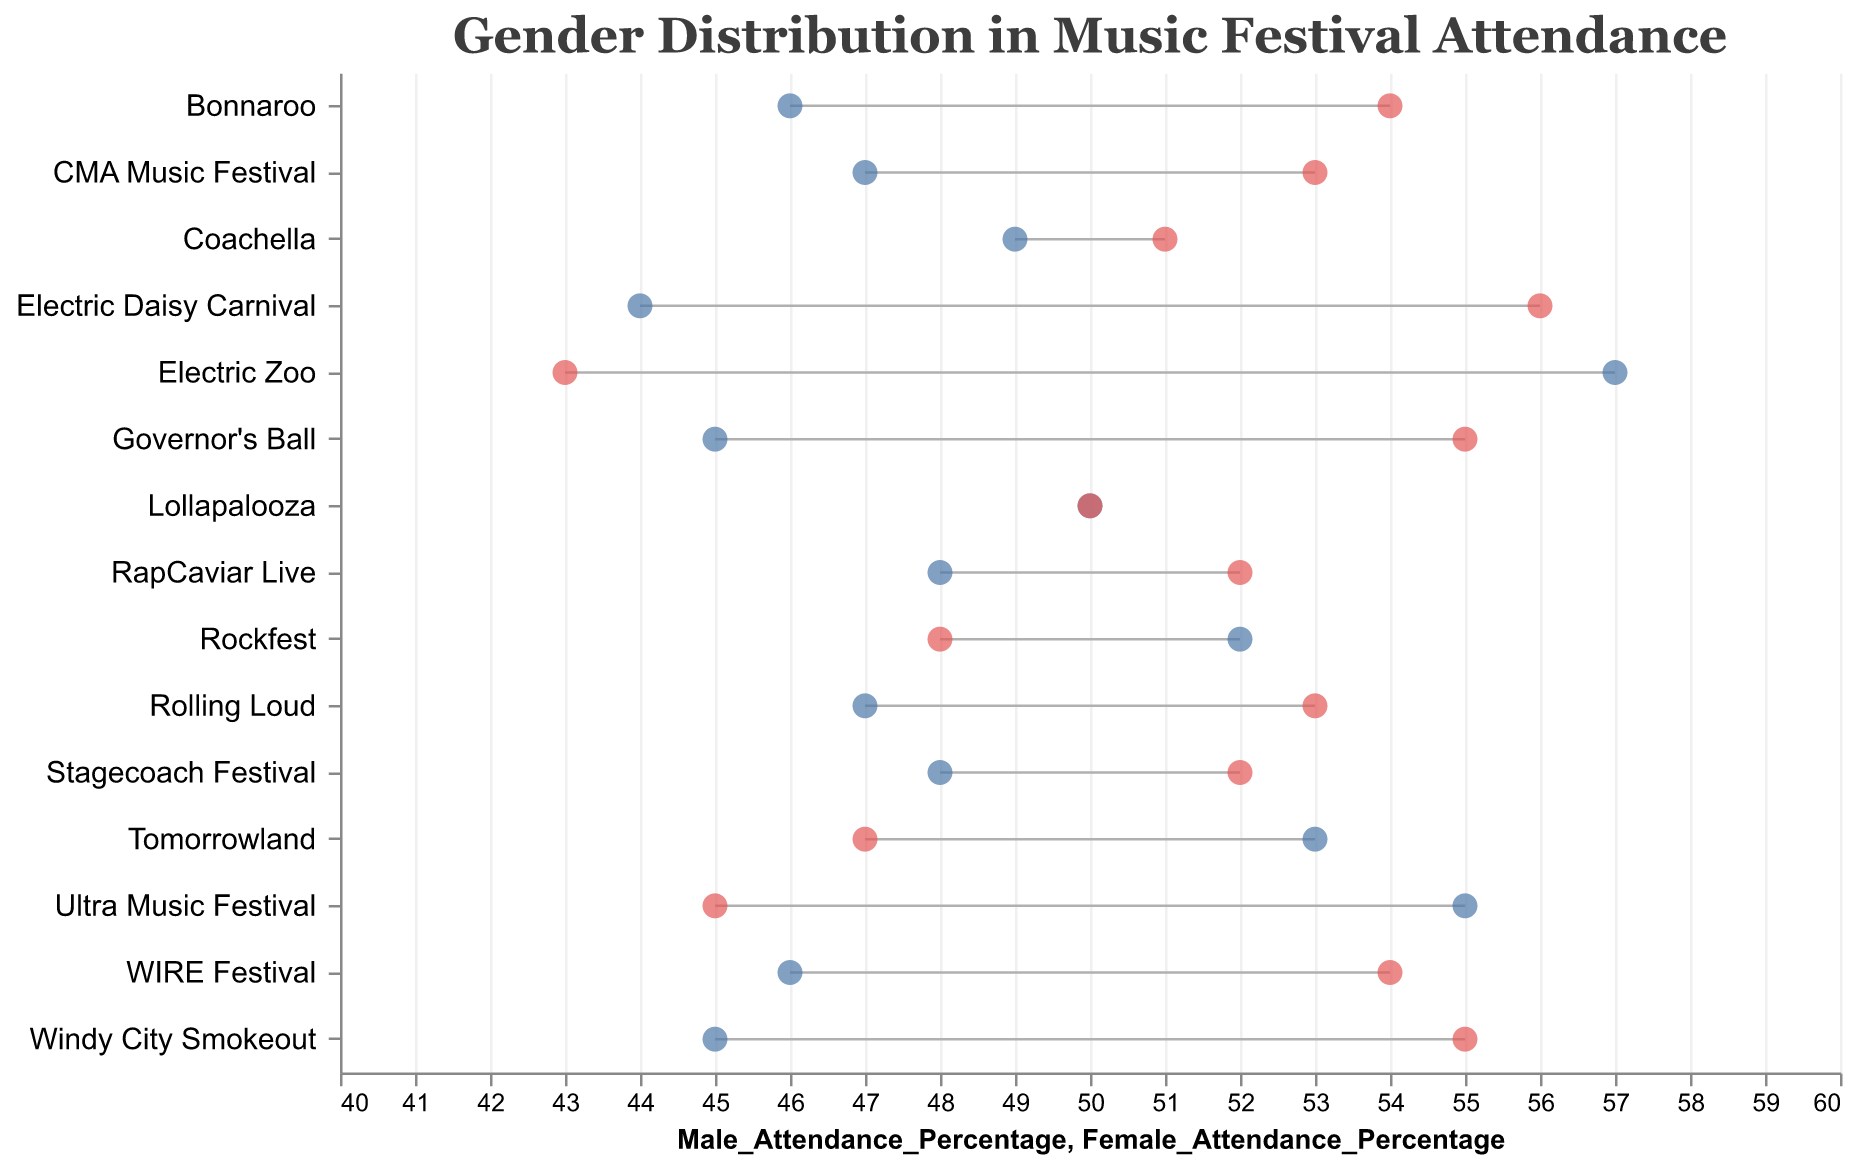What is the title of the figure? The title is usually placed at the top of the figure, representing the main subject. Here, it states: "Gender Distribution in Music Festival Attendance".
Answer: Gender Distribution in Music Festival Attendance Which Country music festival has the highest percentage of female attendees? The Dumbbell Plot shows female attendance percentages as red dots. By looking at the Country genre, Windy City Smokeout shows the highest female attendance at 55%.
Answer: Windy City Smokeout What is the difference in female attendance percentage between CMA Music Festival and Rolling Loud? CMA Music Festival has a female attendance of 53% and Rolling Loud has 53% as well. Subtracting these values gives 0.
Answer: 0% Which music genre has the highest male attendance overall? The Dumbbell Plot categorizes events by genre and shows male attendance as blue dots. By observing the plot, the Electronic genre (Ultra Music Festival at 55%, Tomorrowland at 53%, Electric Zoo at 57%) has the highest male attendance.
Answer: Electronic By how much does female attendance at Electric Daisy Carnival exceed male attendance? Electric Daisy Carnival has a male attendance of 44% and a female attendance of 56%. Subtracting 44% from 56% gives 12%.
Answer: 12% Are there any festivals where male and female attendance is exactly equal? Analyzing the Dumbbell Plot, Lollapalooza shows male and female attendance both at 50%.
Answer: Yes, Lollapalooza Which festival in the Pop genre has the lowest male attendance percentage? The Plot shows male attendance in the Pop genre with Bonnaroo (46%), Electric Daisy Carnival (44%), and Governor's Ball (45%). Electric Daisy Carnival has the lowest at 44%.
Answer: Electric Daisy Carnival How does the average female attendance in Country music festivals compare to the average in Rock festivals? Calculate the female attendance average for Country (52%, 53%, 55%) and Rock (51%, 50%, 48%). Country: (52 + 53 + 55) / 3 = 53.33%. Rock: (51 + 50 + 48) / 3 = 49.67%.
Answer: Higher in Country What is the range of male attendance percentages across all listed Electronic music festivals? The Dumbbell Plot shows male attendance for Ultra Music Festival (55%), Tomorrowland (53%), and Electric Zoo (57%). The range is 57% - 53% = 4%.
Answer: 4% 